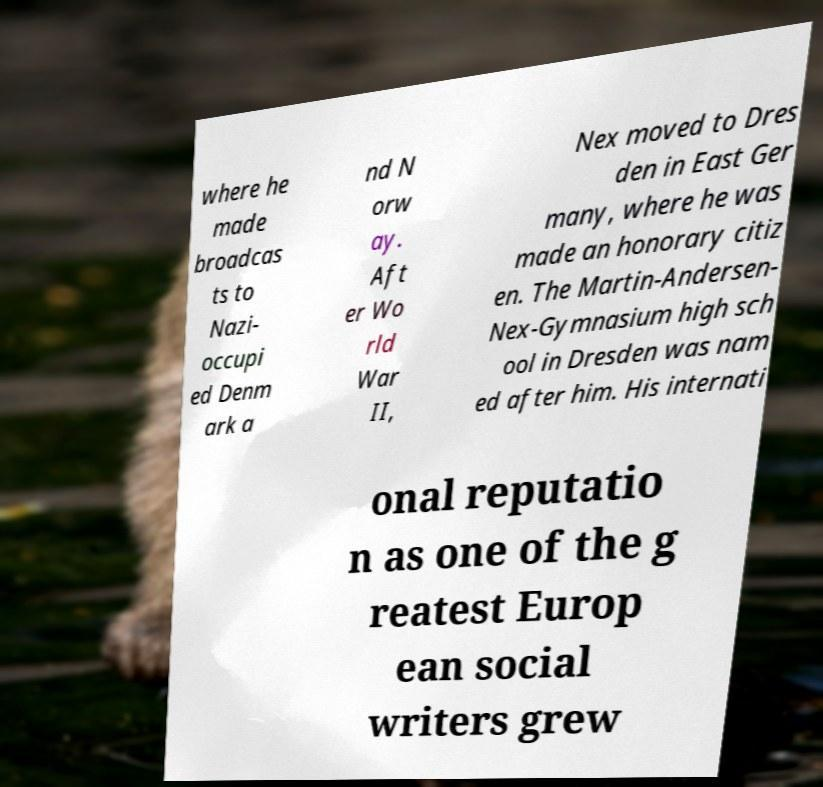Could you assist in decoding the text presented in this image and type it out clearly? where he made broadcas ts to Nazi- occupi ed Denm ark a nd N orw ay. Aft er Wo rld War II, Nex moved to Dres den in East Ger many, where he was made an honorary citiz en. The Martin-Andersen- Nex-Gymnasium high sch ool in Dresden was nam ed after him. His internati onal reputatio n as one of the g reatest Europ ean social writers grew 